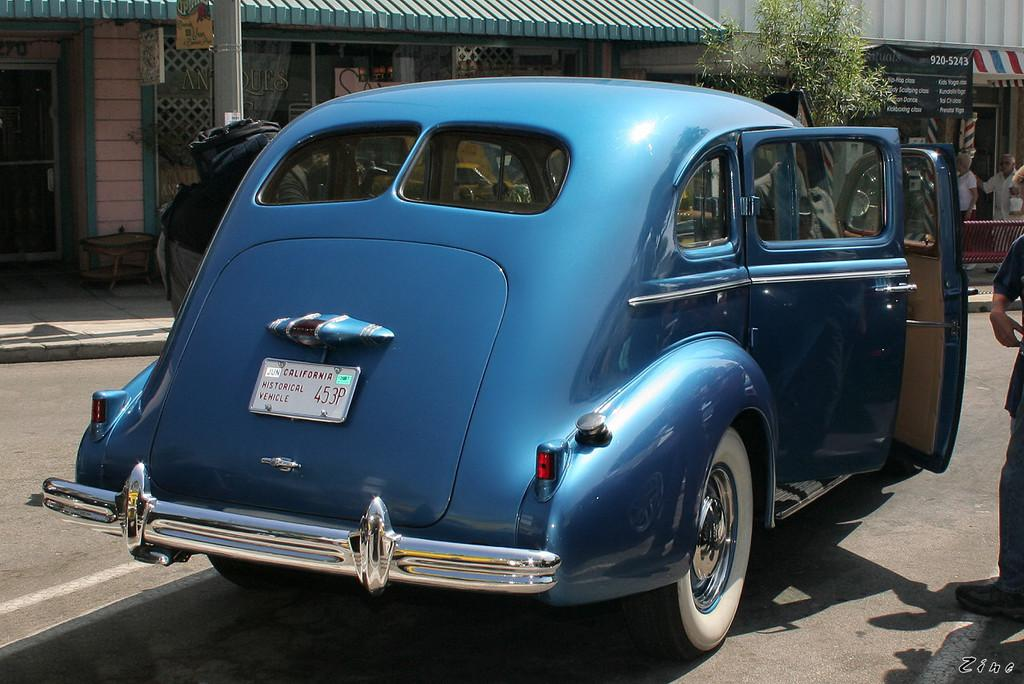What type of establishment can be seen in the image? There are stores in the image. What mode of transportation is visible on the road? There is a car on the road in the image. Are there any natural elements present in the image? Yes, there is a plant in the image. How many people can be seen in the image? There are many people in the image. What type of ant can be seen walking in rhythm in the image? There are no ants present in the image, and the concept of rhythm is not applicable to the image. 